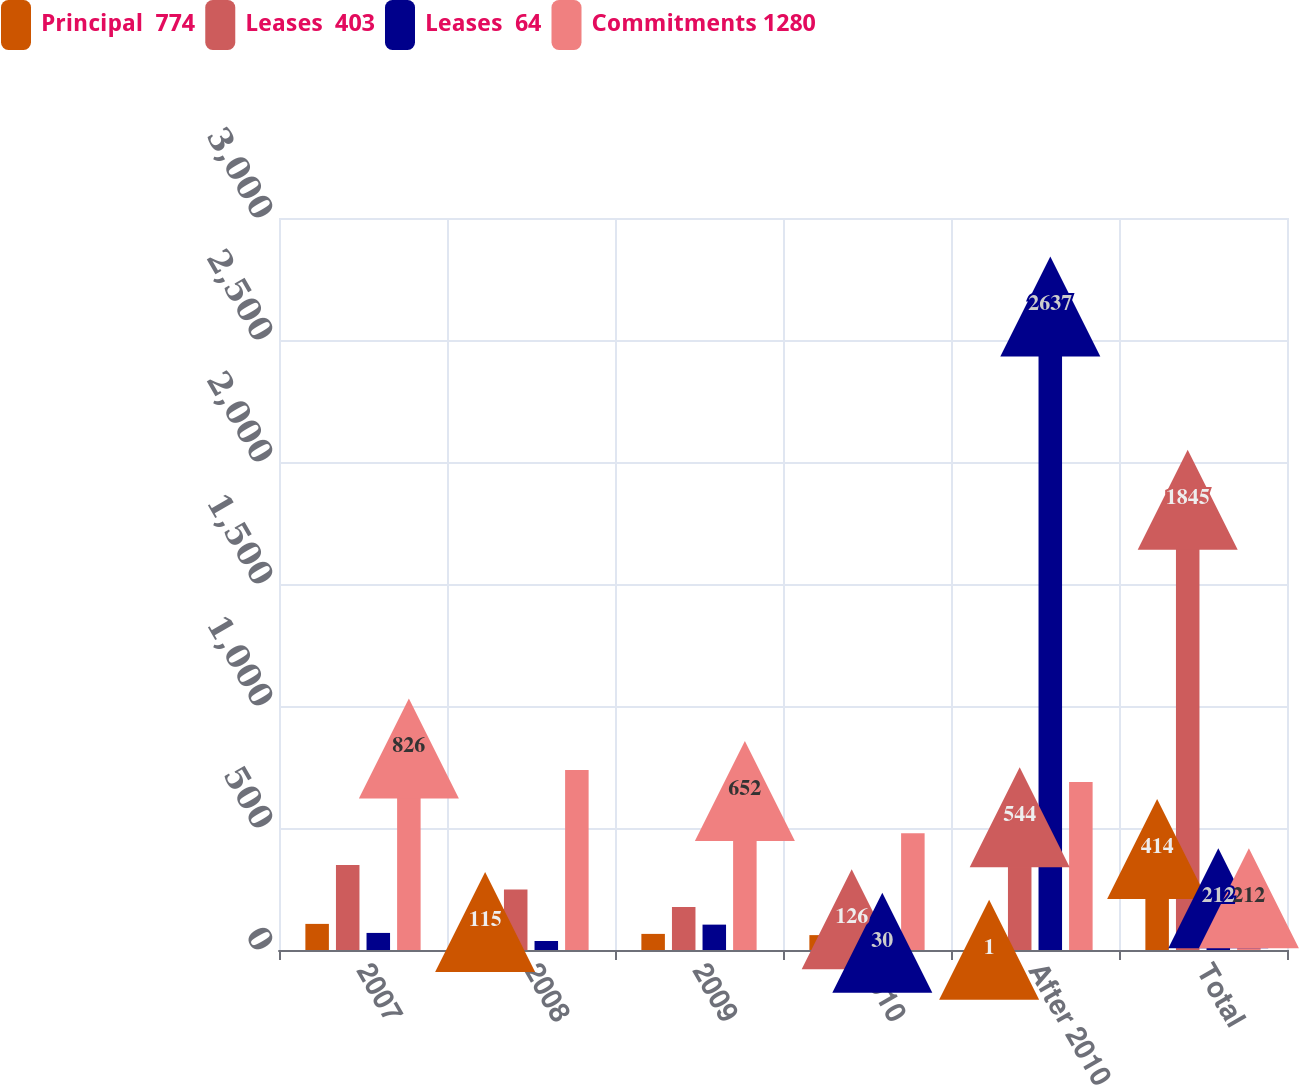<chart> <loc_0><loc_0><loc_500><loc_500><stacked_bar_chart><ecel><fcel>2007<fcel>2008<fcel>2009<fcel>2010<fcel>After 2010<fcel>Total<nl><fcel>Principal  774<fcel>107<fcel>115<fcel>66<fcel>61<fcel>1<fcel>414<nl><fcel>Leases  403<fcel>348<fcel>248<fcel>176<fcel>126<fcel>544<fcel>1845<nl><fcel>Leases  64<fcel>70<fcel>37<fcel>104<fcel>30<fcel>2637<fcel>212<nl><fcel>Commitments 1280<fcel>826<fcel>738<fcel>652<fcel>478<fcel>689<fcel>212<nl></chart> 